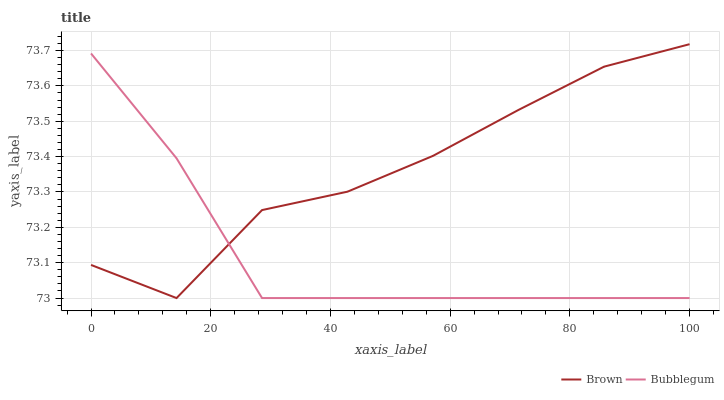Does Bubblegum have the minimum area under the curve?
Answer yes or no. Yes. Does Brown have the maximum area under the curve?
Answer yes or no. Yes. Does Bubblegum have the maximum area under the curve?
Answer yes or no. No. Is Bubblegum the smoothest?
Answer yes or no. Yes. Is Brown the roughest?
Answer yes or no. Yes. Is Bubblegum the roughest?
Answer yes or no. No. Does Brown have the lowest value?
Answer yes or no. Yes. Does Brown have the highest value?
Answer yes or no. Yes. Does Bubblegum have the highest value?
Answer yes or no. No. Does Brown intersect Bubblegum?
Answer yes or no. Yes. Is Brown less than Bubblegum?
Answer yes or no. No. Is Brown greater than Bubblegum?
Answer yes or no. No. 